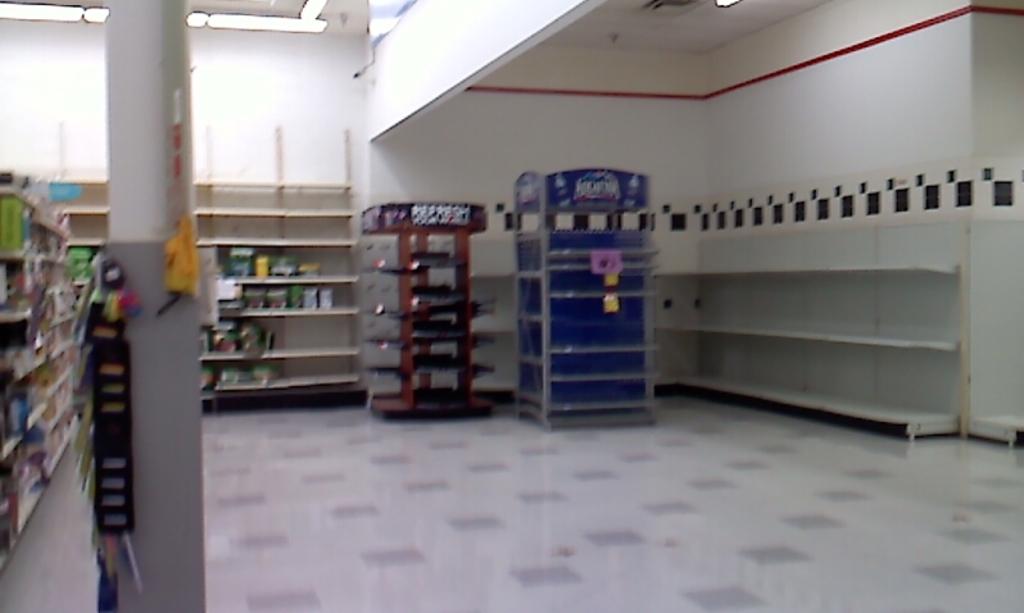What is the brand name of water in the blue machine?
Ensure brevity in your answer.  Aquafina. 